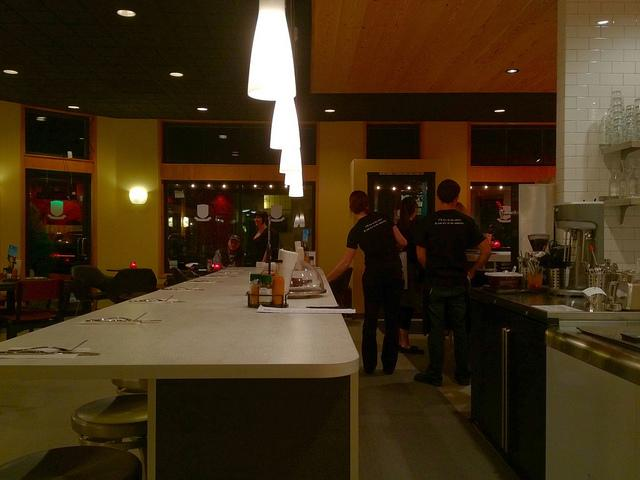What type of counter is shown? Please explain your reasoning. restaurant. The counter is a bar type counter where people can sit to be served food and drink. 